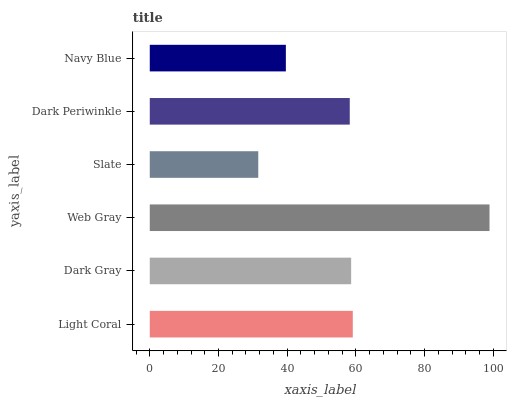Is Slate the minimum?
Answer yes or no. Yes. Is Web Gray the maximum?
Answer yes or no. Yes. Is Dark Gray the minimum?
Answer yes or no. No. Is Dark Gray the maximum?
Answer yes or no. No. Is Light Coral greater than Dark Gray?
Answer yes or no. Yes. Is Dark Gray less than Light Coral?
Answer yes or no. Yes. Is Dark Gray greater than Light Coral?
Answer yes or no. No. Is Light Coral less than Dark Gray?
Answer yes or no. No. Is Dark Gray the high median?
Answer yes or no. Yes. Is Dark Periwinkle the low median?
Answer yes or no. Yes. Is Web Gray the high median?
Answer yes or no. No. Is Dark Gray the low median?
Answer yes or no. No. 